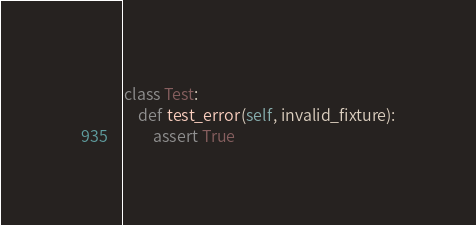<code> <loc_0><loc_0><loc_500><loc_500><_Python_>class Test:
    def test_error(self, invalid_fixture):
        assert True
</code> 